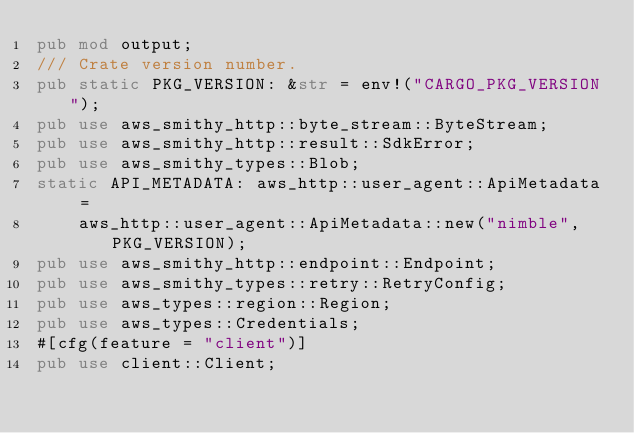<code> <loc_0><loc_0><loc_500><loc_500><_Rust_>pub mod output;
/// Crate version number.
pub static PKG_VERSION: &str = env!("CARGO_PKG_VERSION");
pub use aws_smithy_http::byte_stream::ByteStream;
pub use aws_smithy_http::result::SdkError;
pub use aws_smithy_types::Blob;
static API_METADATA: aws_http::user_agent::ApiMetadata =
    aws_http::user_agent::ApiMetadata::new("nimble", PKG_VERSION);
pub use aws_smithy_http::endpoint::Endpoint;
pub use aws_smithy_types::retry::RetryConfig;
pub use aws_types::region::Region;
pub use aws_types::Credentials;
#[cfg(feature = "client")]
pub use client::Client;
</code> 